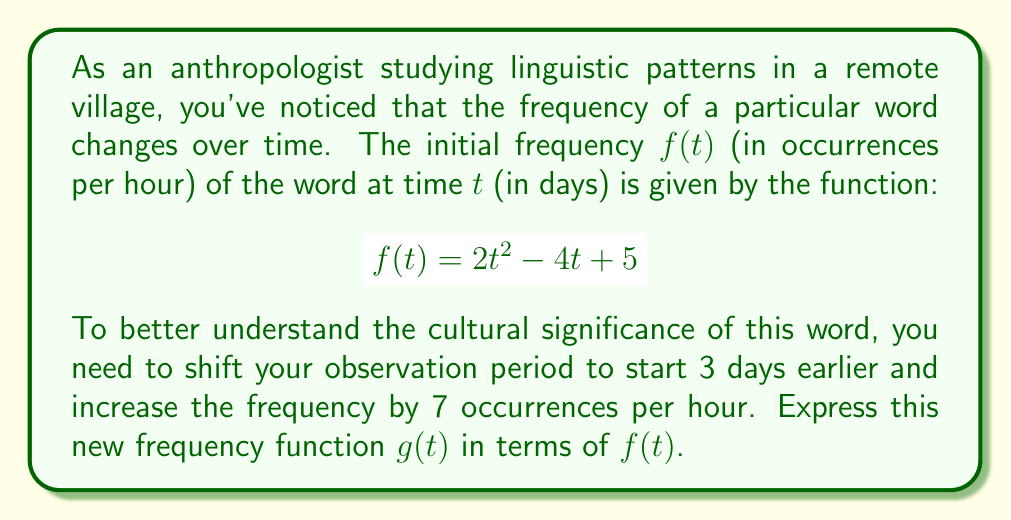Help me with this question. To solve this problem, we need to apply two transformations to the original function $f(t)$:

1. Shift the function 3 days earlier:
   This means replacing $t$ with $(t+3)$ in the original function.
   
2. Increase the frequency by 7 occurrences per hour:
   This means adding 7 to the entire function.

Let's apply these transformations step by step:

1. First, we replace $t$ with $(t+3)$ in $f(t)$:
   $$f(t+3) = 2(t+3)^2 - 4(t+3) + 5$$

2. Now, we add 7 to this new function to get $g(t)$:
   $$g(t) = f(t+3) + 7$$

3. Substituting the expression for $f(t+3)$:
   $$g(t) = [2(t+3)^2 - 4(t+3) + 5] + 7$$

4. Simplifying:
   $$g(t) = 2(t+3)^2 - 4(t+3) + 12$$

5. Expanding $(t+3)^2$:
   $$g(t) = 2(t^2 + 6t + 9) - 4t - 12 + 12$$

6. Further simplifying:
   $$g(t) = 2t^2 + 12t + 18 - 4t - 12 + 12$$
   $$g(t) = 2t^2 + 8t + 18$$

Therefore, the new frequency function $g(t)$ can be expressed as:
$$g(t) = f(t+3) + 7$$
or in its expanded form:
$$g(t) = 2t^2 + 8t + 18$$
Answer: $g(t) = f(t+3) + 7$ or $g(t) = 2t^2 + 8t + 18$ 